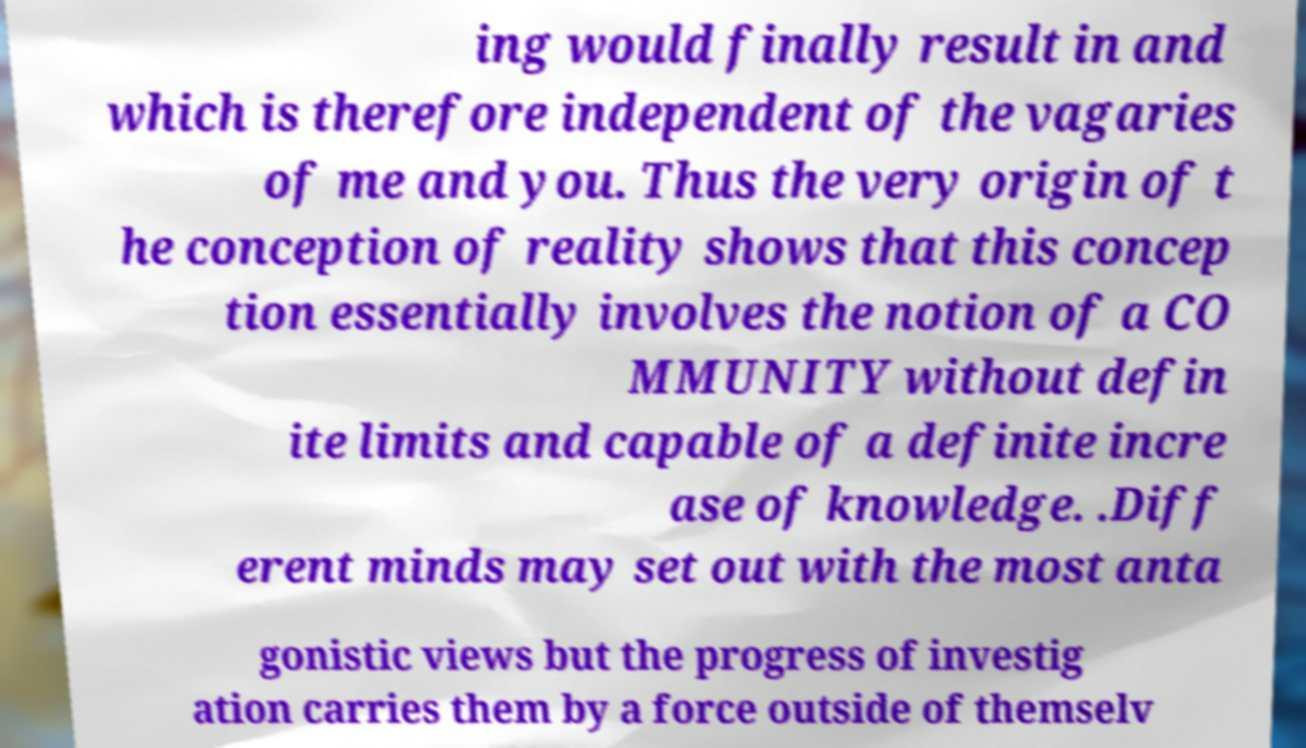Please read and relay the text visible in this image. What does it say? ing would finally result in and which is therefore independent of the vagaries of me and you. Thus the very origin of t he conception of reality shows that this concep tion essentially involves the notion of a CO MMUNITY without defin ite limits and capable of a definite incre ase of knowledge. .Diff erent minds may set out with the most anta gonistic views but the progress of investig ation carries them by a force outside of themselv 